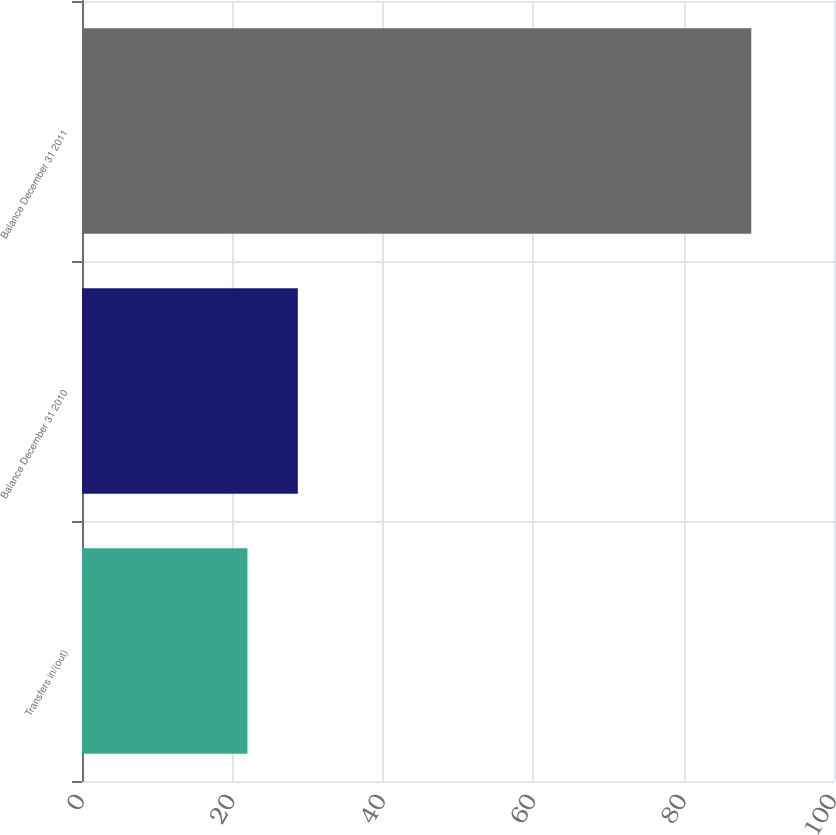<chart> <loc_0><loc_0><loc_500><loc_500><bar_chart><fcel>Transfers in/(out)<fcel>Balance December 31 2010<fcel>Balance December 31 2011<nl><fcel>22<fcel>28.7<fcel>89<nl></chart> 